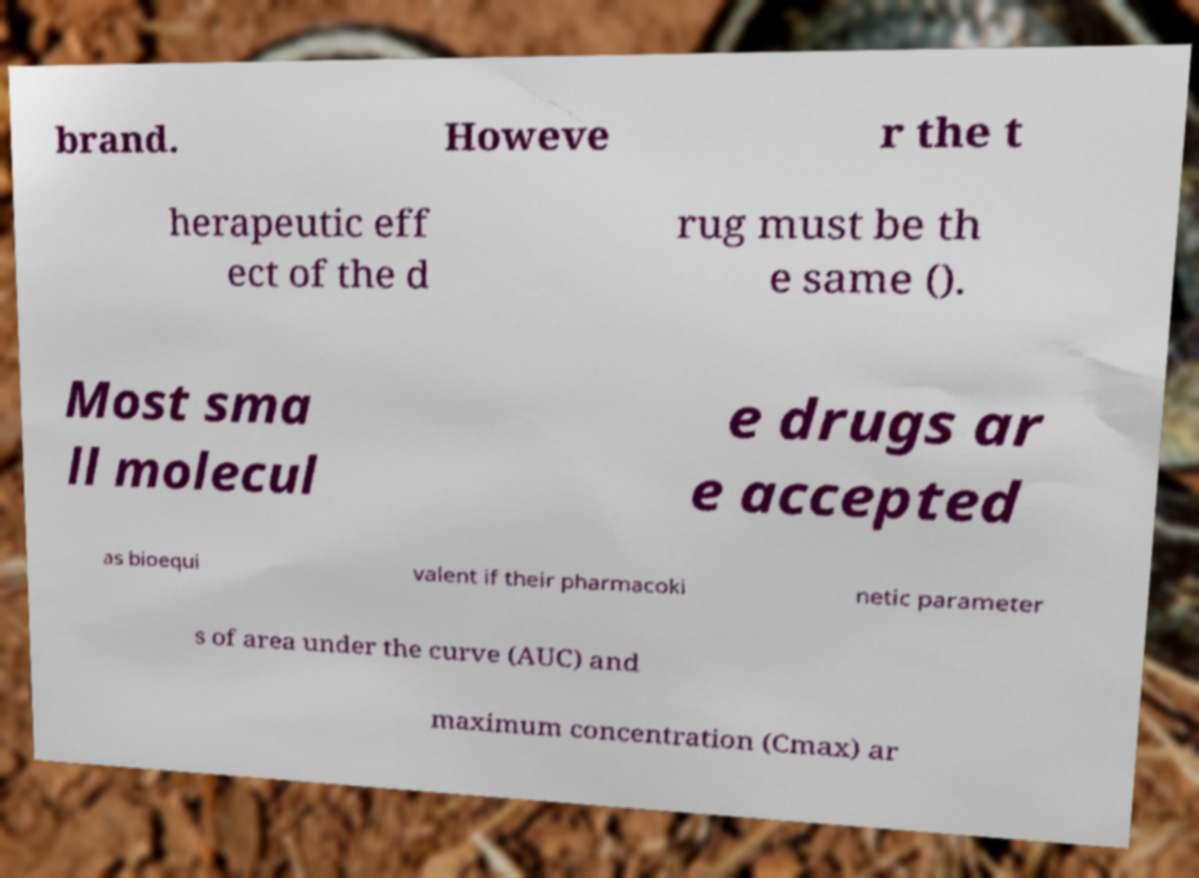Could you assist in decoding the text presented in this image and type it out clearly? brand. Howeve r the t herapeutic eff ect of the d rug must be th e same (). Most sma ll molecul e drugs ar e accepted as bioequi valent if their pharmacoki netic parameter s of area under the curve (AUC) and maximum concentration (Cmax) ar 